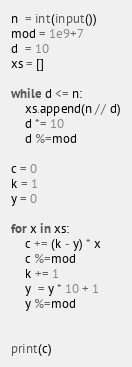<code> <loc_0><loc_0><loc_500><loc_500><_Python_>n  = int(input())
mod = 1e9+7
d  = 10
xs = []

while d <= n:
	xs.append(n // d)
	d *= 10
    d %=mod

c = 0
k = 1
y = 0

for x in xs:
	c += (k - y) * x
    c %=mod
	k += 1
	y  = y * 10 + 1
    y %=mod
    

print(c)

</code> 